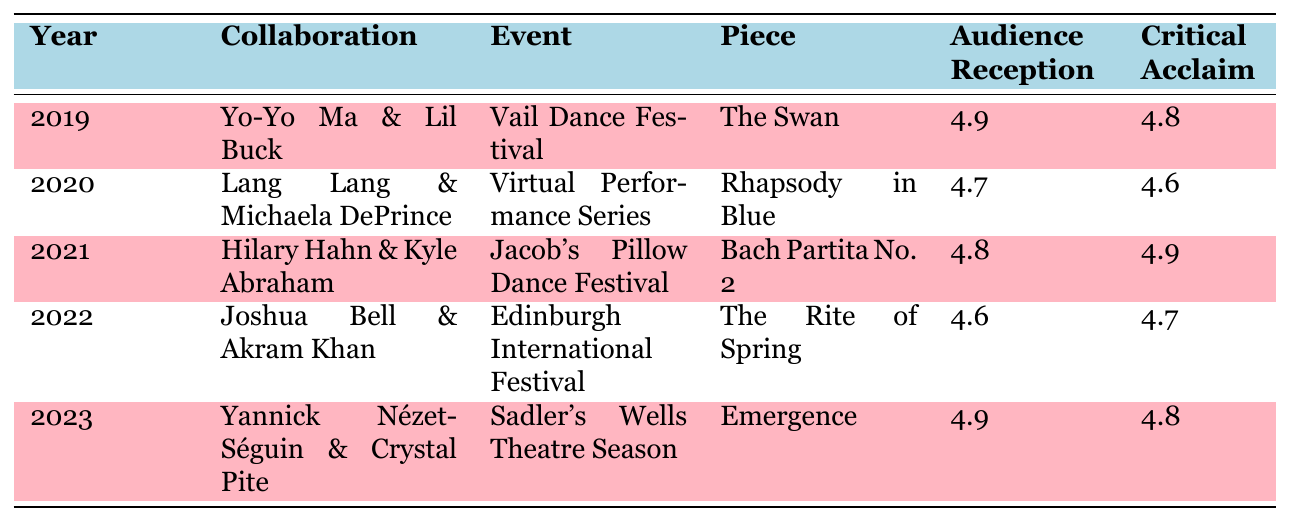What was the highest audience reception score recorded in the table? The highest audience reception score is found by looking for the highest value in the "Audience Reception" column. The scores are 4.9 (Yo-Yo Ma & Lil Buck, 2019), 4.7 (Lang Lang & Michaela DePrince, 2020), 4.8 (Hilary Hahn & Kyle Abraham, 2021), 4.6 (Joshua Bell & Akram Khan, 2022), and 4.9 (Yannick Nézet-Séguin & Crystal Pite, 2023). The maximum score is 4.9.
Answer: 4.9 Which collaboration took place at the Sadler's Wells Theatre? By examining the "Event" and "Venue" columns, we can see that the collaboration that happened at "Sadler's Wells Theatre" is "Yannick Nézet-Séguin & Crystal Pite".
Answer: Yannick Nézet-Séguin & Crystal Pite In which year did Hilary Hahn collaborate with Kyle Abraham? The table shows the collaboration between Hilary Hahn and Kyle Abraham took place in 2021 as per the "Year" column.
Answer: 2021 What is the average critical acclaim rating across all collaborations? To calculate the average critical acclaim, sum the scores: (4.8 + 4.6 + 4.9 + 4.7 + 4.8) = 24.8. There are 5 data points, so dividing gives 24.8 / 5 = 4.96.
Answer: 4.96 Did any collaboration receive a critical acclaim score of 5.0? Looking at the "Critical Acclaim" column, the scores are 4.8, 4.6, 4.9, 4.7, and 4.8. No score reached 5.0, so the answer is No.
Answer: No Which classical musician collaborated with the contemporary dancer Akram Khan? By checking the "Contemporary Dancer" column, we find that Joshua Bell collaborated with Akram Khan in 2022.
Answer: Joshua Bell What was the difference between the lowest and highest audience reception scores? The lowest audience reception score is 4.6 (Joshua Bell & Akram Khan, 2022) and the highest is 4.9 (both Yo-Yo Ma & Lil Buck, 2019, and Yannick Nézet-Séguin & Crystal Pite, 2023). The difference is 4.9 - 4.6 = 0.3.
Answer: 0.3 How many collaborations featured an audience reception score of 4.9? By counting the number of times 4.9 appears in the "Audience Reception" column, we find it appears twice: for Yo-Yo Ma & Lil Buck (2019) and Yannick Nézet-Séguin & Crystal Pite (2023).
Answer: 2 